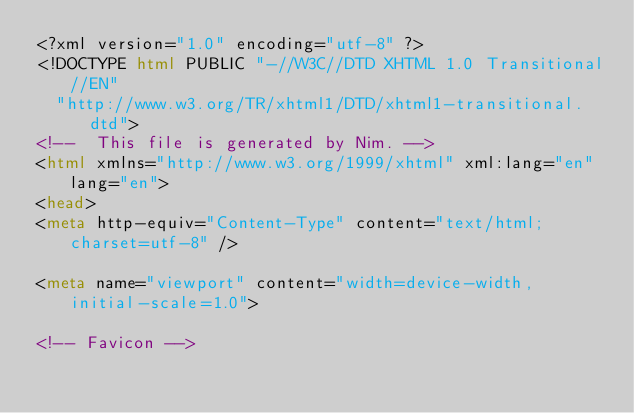Convert code to text. <code><loc_0><loc_0><loc_500><loc_500><_HTML_><?xml version="1.0" encoding="utf-8" ?>
<!DOCTYPE html PUBLIC "-//W3C//DTD XHTML 1.0 Transitional//EN"
  "http://www.w3.org/TR/xhtml1/DTD/xhtml1-transitional.dtd">
<!--  This file is generated by Nim. -->
<html xmlns="http://www.w3.org/1999/xhtml" xml:lang="en" lang="en">
<head>
<meta http-equiv="Content-Type" content="text/html; charset=utf-8" />

<meta name="viewport" content="width=device-width, initial-scale=1.0">

<!-- Favicon --></code> 